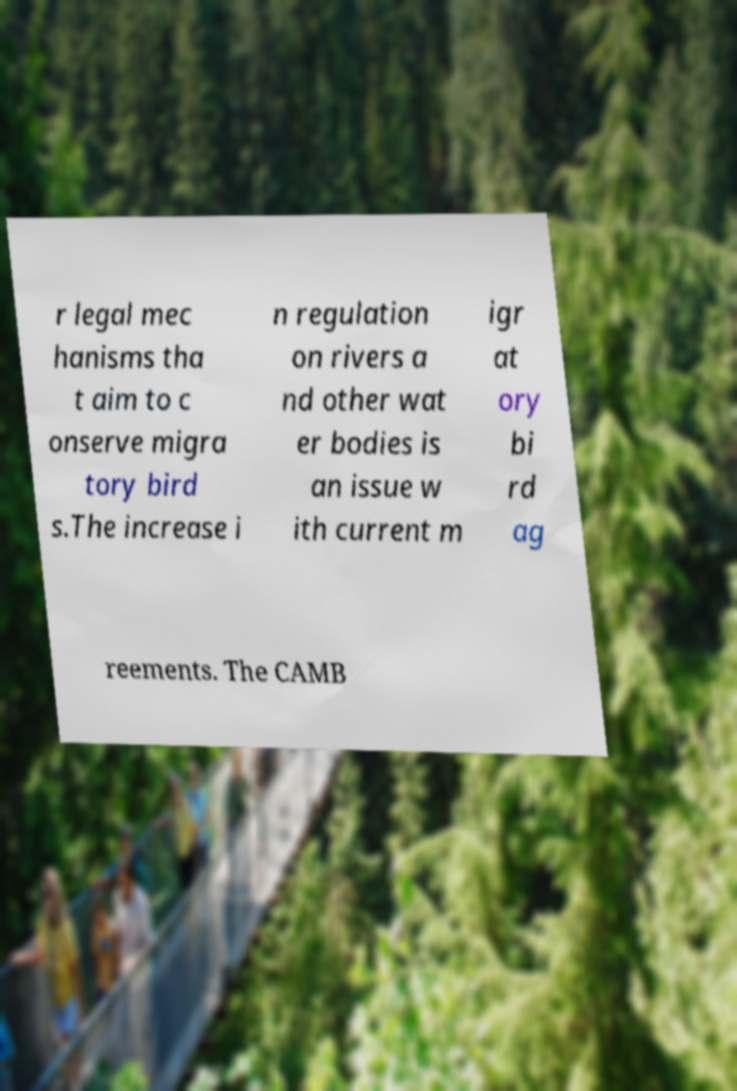Can you accurately transcribe the text from the provided image for me? r legal mec hanisms tha t aim to c onserve migra tory bird s.The increase i n regulation on rivers a nd other wat er bodies is an issue w ith current m igr at ory bi rd ag reements. The CAMB 